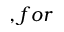<formula> <loc_0><loc_0><loc_500><loc_500>, f o r</formula> 